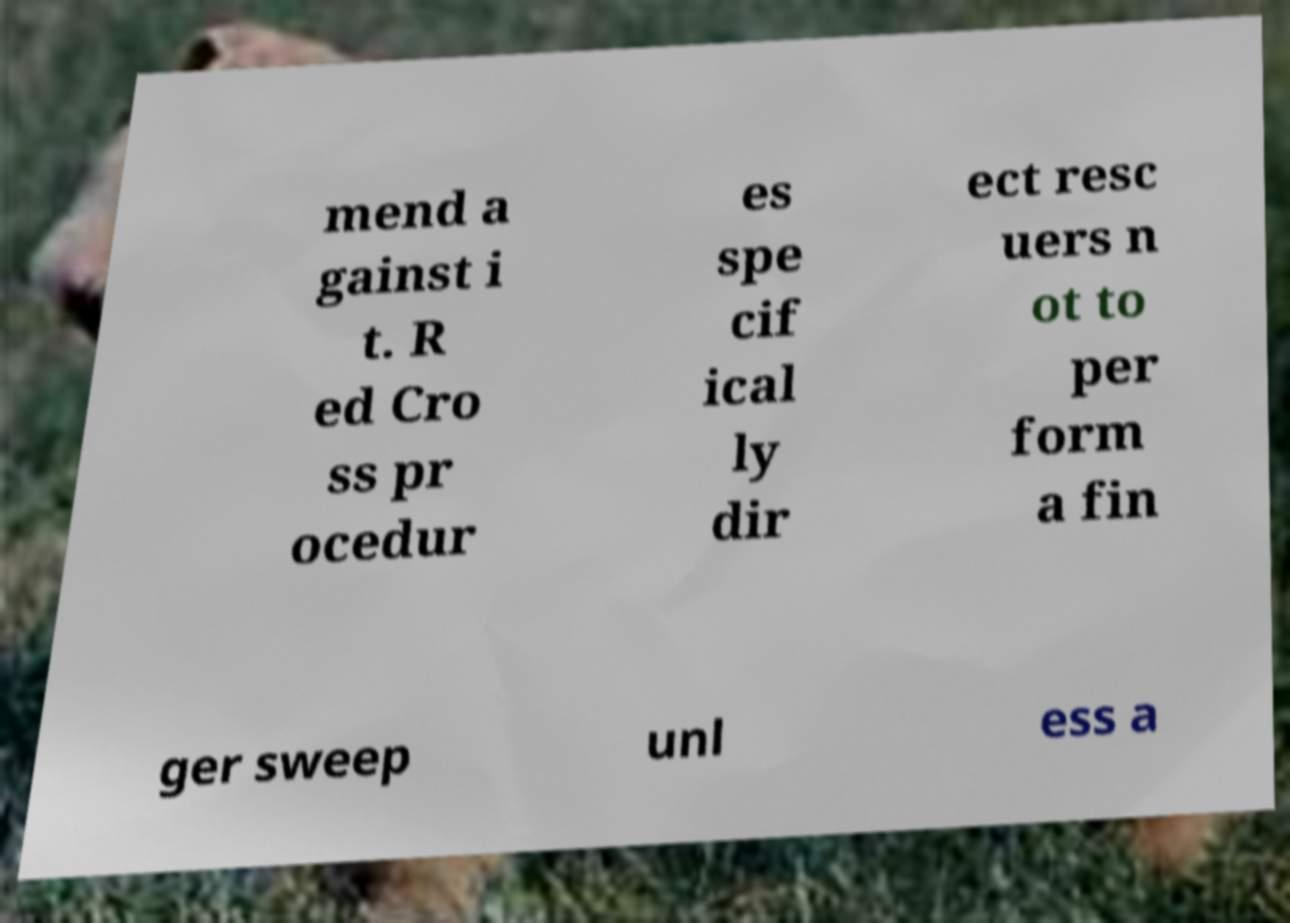What messages or text are displayed in this image? I need them in a readable, typed format. mend a gainst i t. R ed Cro ss pr ocedur es spe cif ical ly dir ect resc uers n ot to per form a fin ger sweep unl ess a 